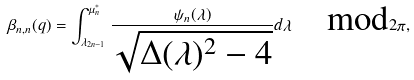<formula> <loc_0><loc_0><loc_500><loc_500>\beta _ { n , n } ( q ) = \int _ { \lambda _ { 2 n - 1 } } ^ { \mu _ { n } ^ { * } } \frac { \psi _ { n } ( \lambda ) } { \sqrt { \Delta ( \lambda ) ^ { 2 } - 4 } } d \lambda \quad \text {mod} 2 \pi ,</formula> 